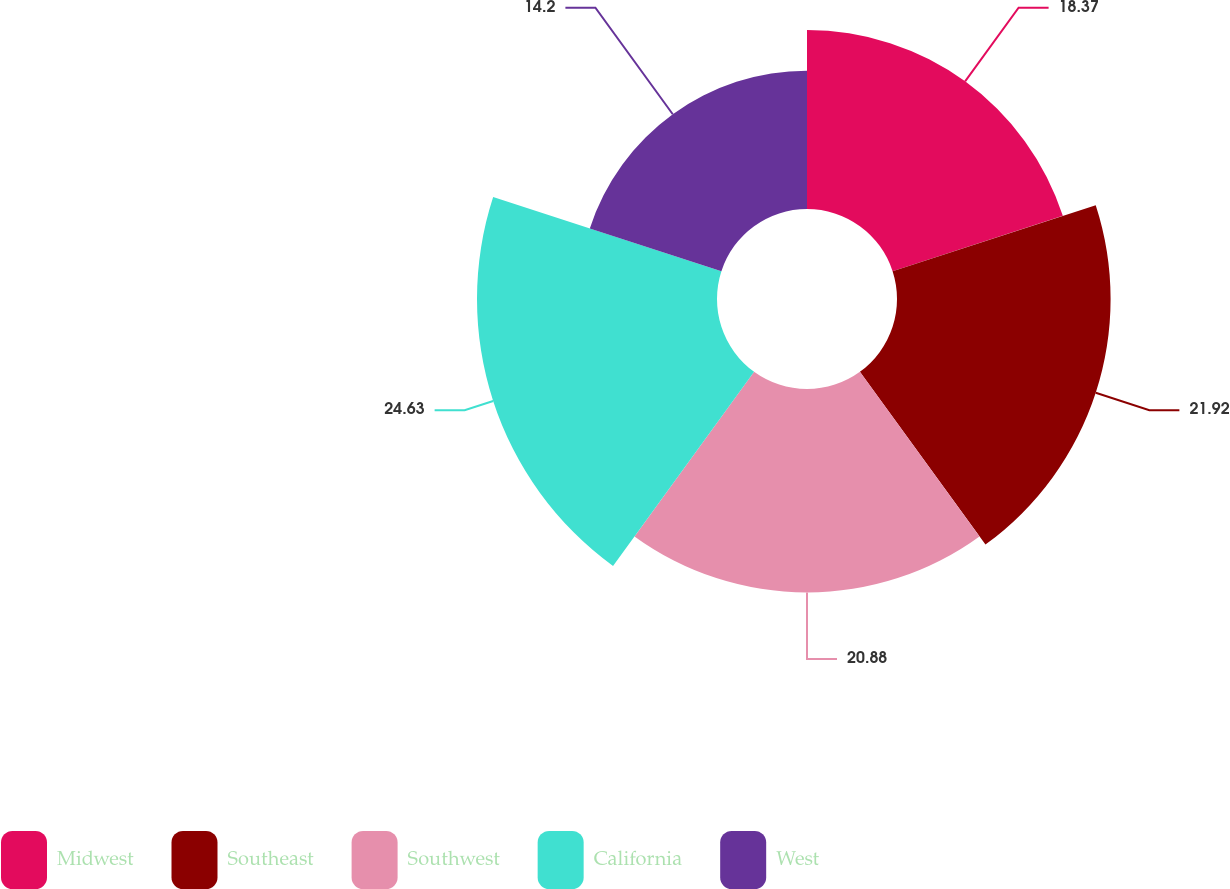<chart> <loc_0><loc_0><loc_500><loc_500><pie_chart><fcel>Midwest<fcel>Southeast<fcel>Southwest<fcel>California<fcel>West<nl><fcel>18.37%<fcel>21.92%<fcel>20.88%<fcel>24.63%<fcel>14.2%<nl></chart> 